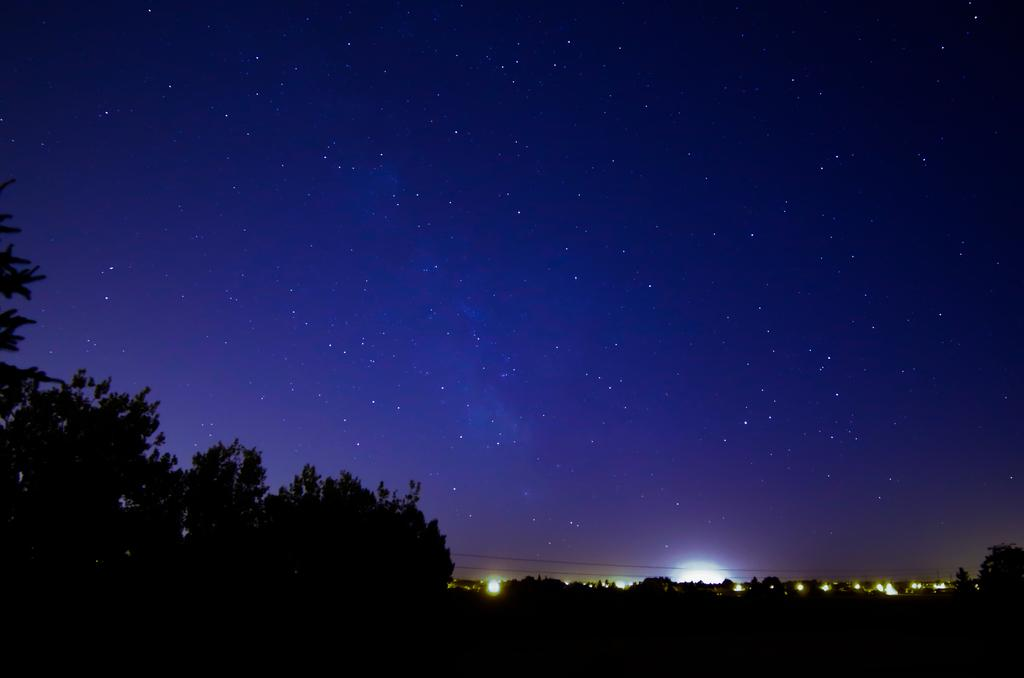At what time of day was the image taken? The image was taken during night time. What can be seen at the bottom of the picture? There are trees and lights at the bottom of the picture. What is visible in the sky in the image? The sky is visible in the image, and stars are present. What type of record can be seen spinning on a turntable in the image? There is no record or turntable present in the image. What is the texture of the chin of the person in the image? There is no person present in the image, so it is not possible to determine the texture of their chin. 